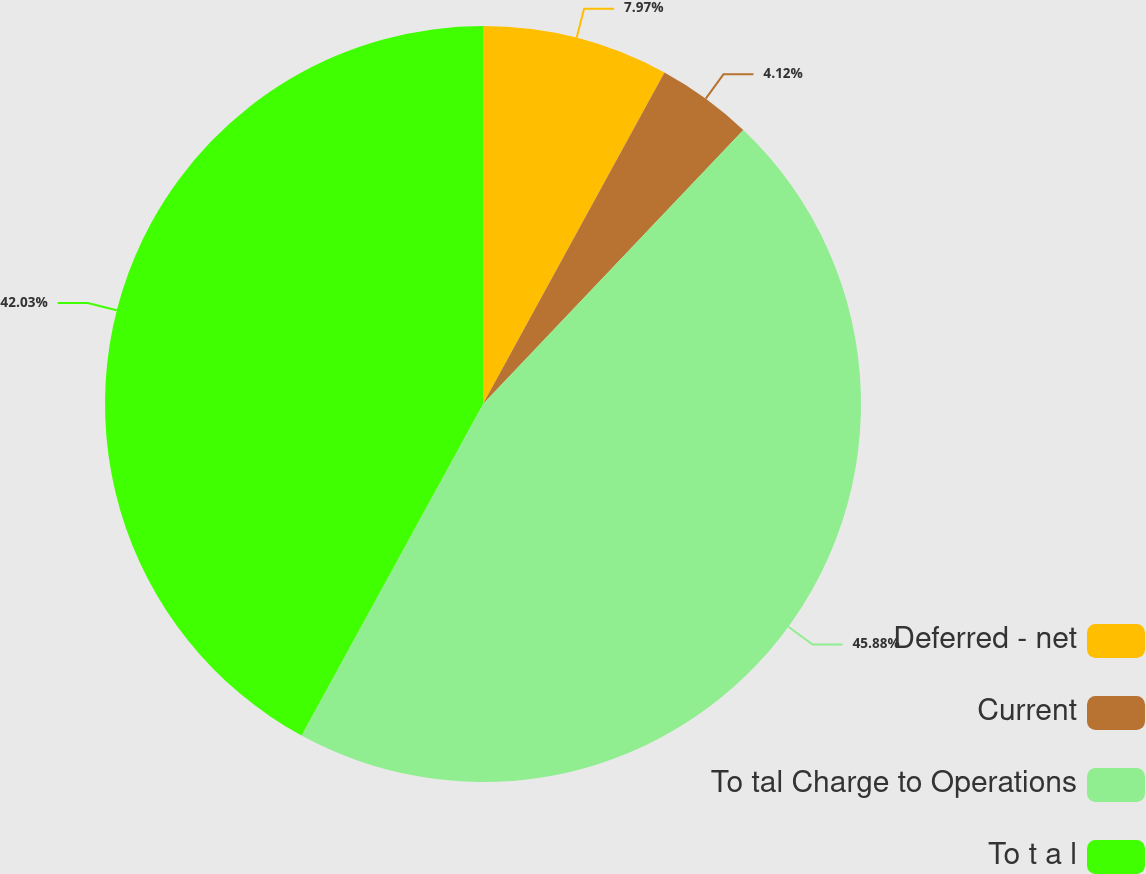<chart> <loc_0><loc_0><loc_500><loc_500><pie_chart><fcel>Deferred - net<fcel>Current<fcel>To tal Charge to Operations<fcel>To t a l<nl><fcel>7.97%<fcel>4.12%<fcel>45.88%<fcel>42.03%<nl></chart> 